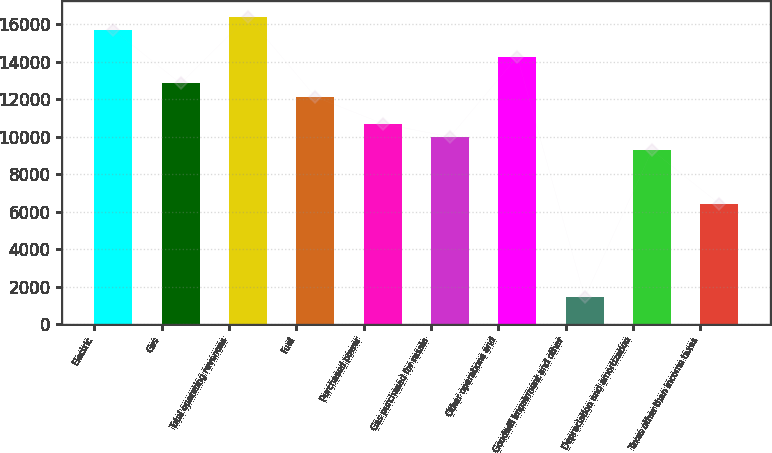Convert chart to OTSL. <chart><loc_0><loc_0><loc_500><loc_500><bar_chart><fcel>Electric<fcel>Gas<fcel>Total operating revenues<fcel>Fuel<fcel>Purchased power<fcel>Gas purchased for resale<fcel>Other operations and<fcel>Goodwill impairment and other<fcel>Depreciation and amortization<fcel>Taxes other than income taxes<nl><fcel>15695.2<fcel>12841.8<fcel>16408.6<fcel>12128.5<fcel>10701.8<fcel>9988.44<fcel>14268.5<fcel>1428.24<fcel>9275.09<fcel>6421.69<nl></chart> 